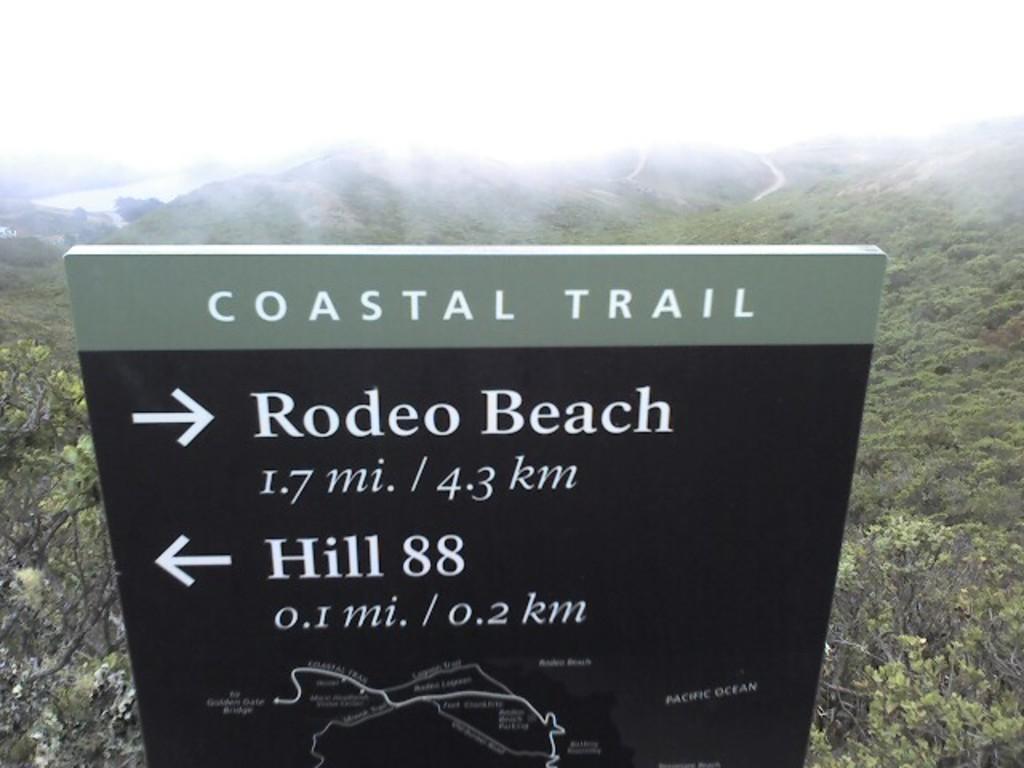Could you give a brief overview of what you see in this image? There is a text board at the bottom of this image and there are some trees in the background. It seems like there are some mountains in the middle of this image, and there is a sky at the top of this image. 